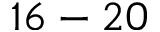<formula> <loc_0><loc_0><loc_500><loc_500>1 6 - 2 0</formula> 